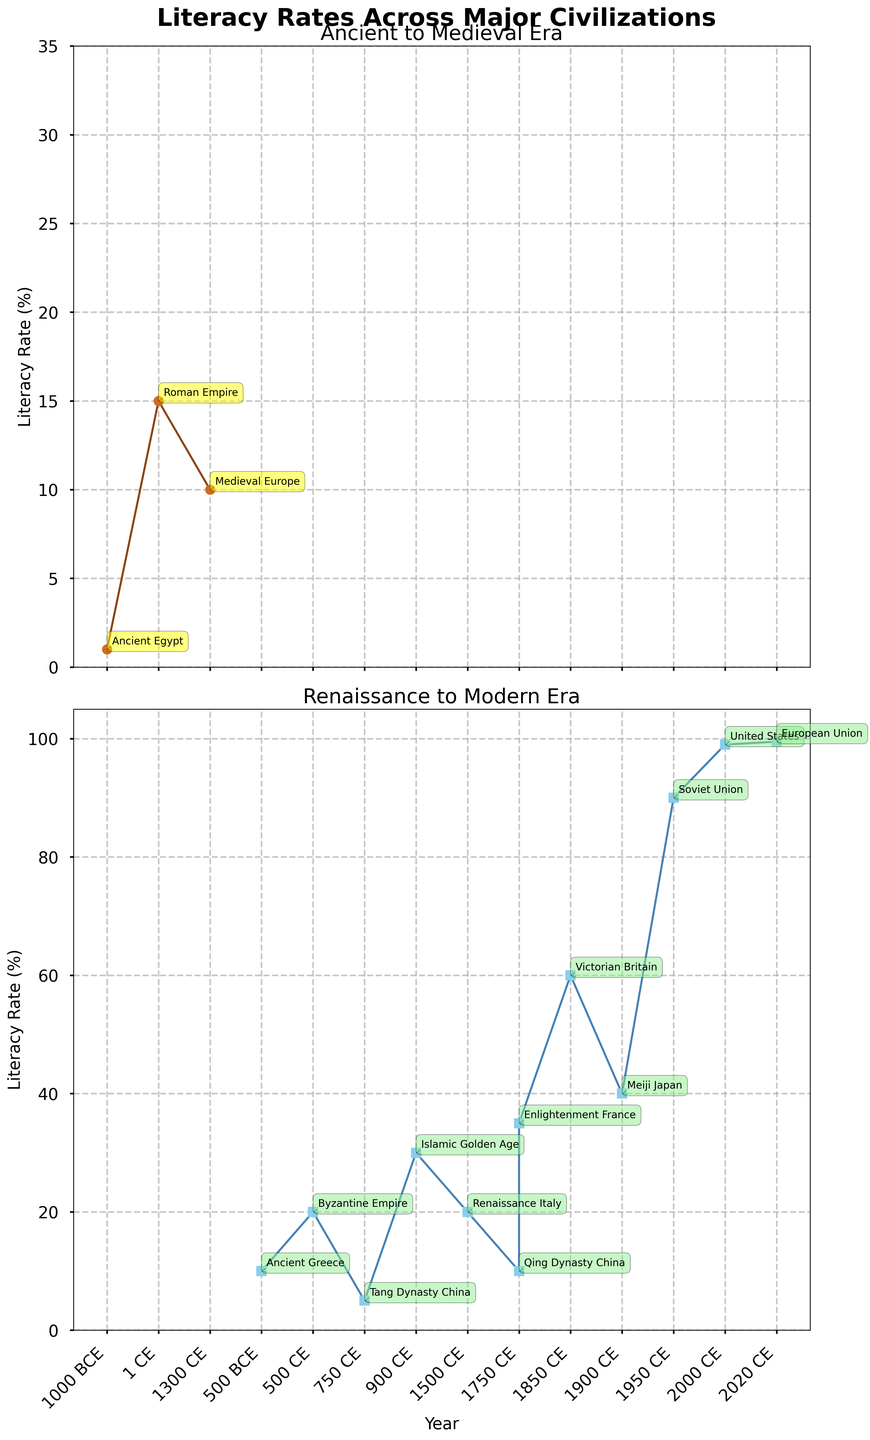What's the title of the figure? The title is located at the top of the figure in large, bold font. It reads, "Literacy Rates Across Major Civilizations."
Answer: Literacy Rates Across Major Civilizations How many eras are compared in the figure? The figure has two vertical subplots with distinct titles: "Ancient to Medieval Era" and "Renaissance to Modern Era," indicating two separate eras are compared.
Answer: Two Which civilization has the lowest literacy rate in the "Ancient to Medieval Era" subplot? In the "Ancient to Medieval Era" subplot, the literacy rate for Ancient Egypt is the lowest at 1%.
Answer: Ancient Egypt How do the literacy rates of the Roman Empire and Byzantine Empire differ? Look at the literacy rate points for the Roman Empire (1 CE) at 15% and Byzantine Empire (500 CE) at 20%. The difference is 5%.
Answer: 5% What is the literacy rate for the United States in the "Renaissance to Modern Era" subplot? The "Renaissance to Modern Era" subplot shows the literacy rate for the United States in 2000 CE at 99%.
Answer: 99% Which period shows the highest leap in literacy rate among the given timeframes? The steepest slope in the "Renaissance to Modern Era" subplot indicates the highest leap. From Soviet Union (1950 CE) at 90% to United States (2000 CE) at 99%, the change is 9%.
Answer: 1950 CE to 2000 CE What's the main color used for the data points in the "Ancient to Medieval Era" subplot? In the "Ancient to Medieval Era" subplot, the color used for data points is a brown hue.
Answer: Brown Comparing the Islamic Golden Age and the Renaissance Italy, which had the higher literacy rate? The Islamic Golden Age (900 CE) had a literacy rate of 30%, whereas Renaissance Italy (1500 CE) had 20%. The Islamic Golden Age had a higher rate.
Answer: Islamic Golden Age What is the difference in literacy rates between Enlightenment France and Qing Dynasty China? Enlightenment France (1750 CE) has a literacy rate of 35%, while Qing Dynasty China (1750 CE) has 10%. The difference is 25%.
Answer: 25% Which civilization in the "Renaissance to Modern Era" subset had the smallest improvement in literacy rate compared to its predecessor? The Qing Dynasty China (1750 CE) and Enlightenment France (1750 CE) have consecutive data points in the "Renaissance to Modern Era." Qing Dynasty China had 10%, and Enlightenment France had 35%. This 25% difference is the smallest compared to other gaps in this era.
Answer: Qing Dynasty China 